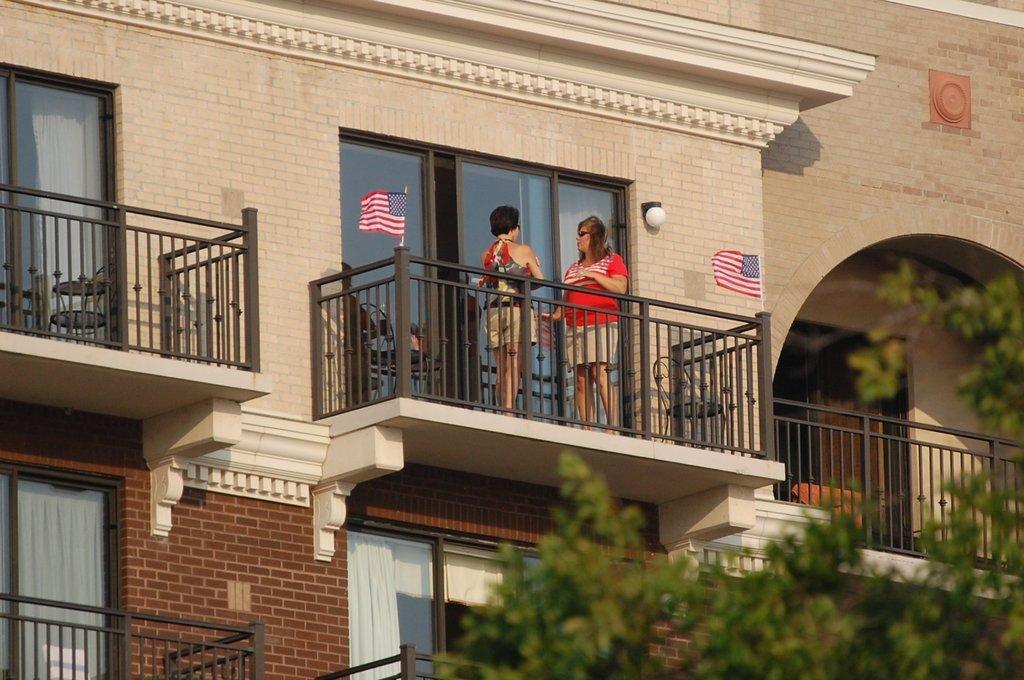Please provide a concise description of this image. In this image we can see the buildings, flags, railing, windows and also the tree. We can also see two women standing. 